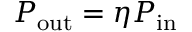<formula> <loc_0><loc_0><loc_500><loc_500>P _ { o u t } = \eta P _ { i n }</formula> 